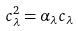Convert formula to latex. <formula><loc_0><loc_0><loc_500><loc_500>c _ { \lambda } ^ { 2 } = \alpha _ { \lambda } c _ { \lambda }</formula> 